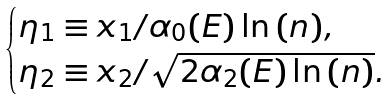Convert formula to latex. <formula><loc_0><loc_0><loc_500><loc_500>\begin{cases} \eta _ { 1 } \equiv x _ { 1 } / \alpha _ { 0 } ( E ) \ln { ( n ) } , \\ \eta _ { 2 } \equiv x _ { 2 } / \sqrt { 2 \alpha _ { 2 } ( E ) \ln { ( n ) } } . \end{cases}</formula> 